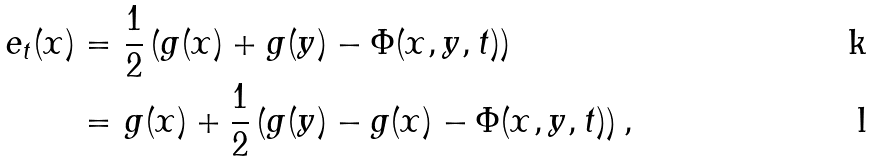Convert formula to latex. <formula><loc_0><loc_0><loc_500><loc_500>e _ { t } ( x ) = & \ \frac { 1 } { 2 } \left ( g ( x ) + g ( y ) - \Phi ( x , y , t ) \right ) \\ = & \ g ( x ) + \frac { 1 } { 2 } \left ( g ( y ) - g ( x ) - \Phi ( x , y , t ) \right ) ,</formula> 